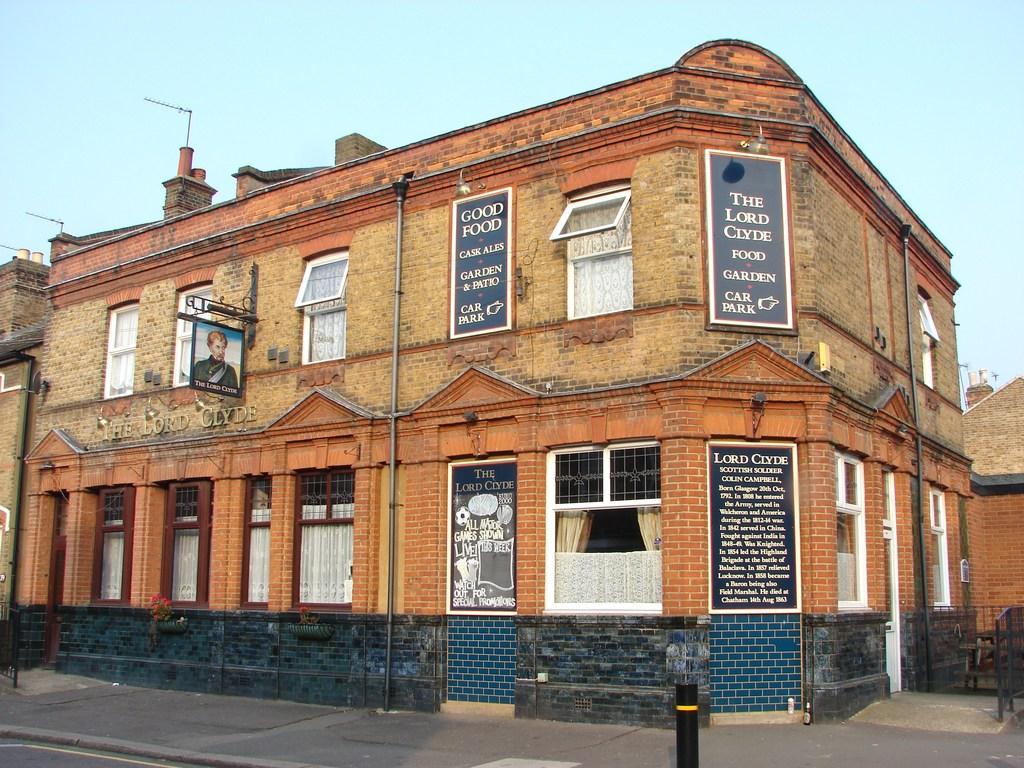Could you give a brief overview of what you see in this image? In this image we can see the building. And we can see the windows and curtains. And we can see the boards on the building and some text written on it. And on the right, we can see the metal fencing, tiny poles. And we can see the sky. 